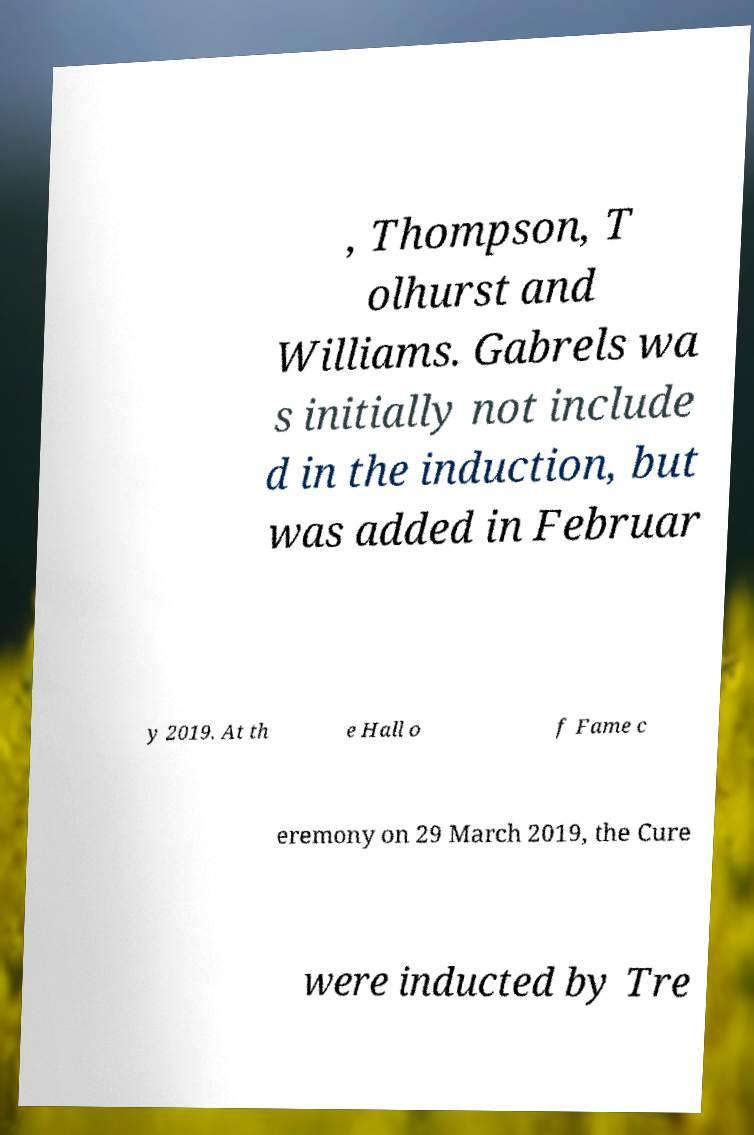Can you accurately transcribe the text from the provided image for me? , Thompson, T olhurst and Williams. Gabrels wa s initially not include d in the induction, but was added in Februar y 2019. At th e Hall o f Fame c eremony on 29 March 2019, the Cure were inducted by Tre 